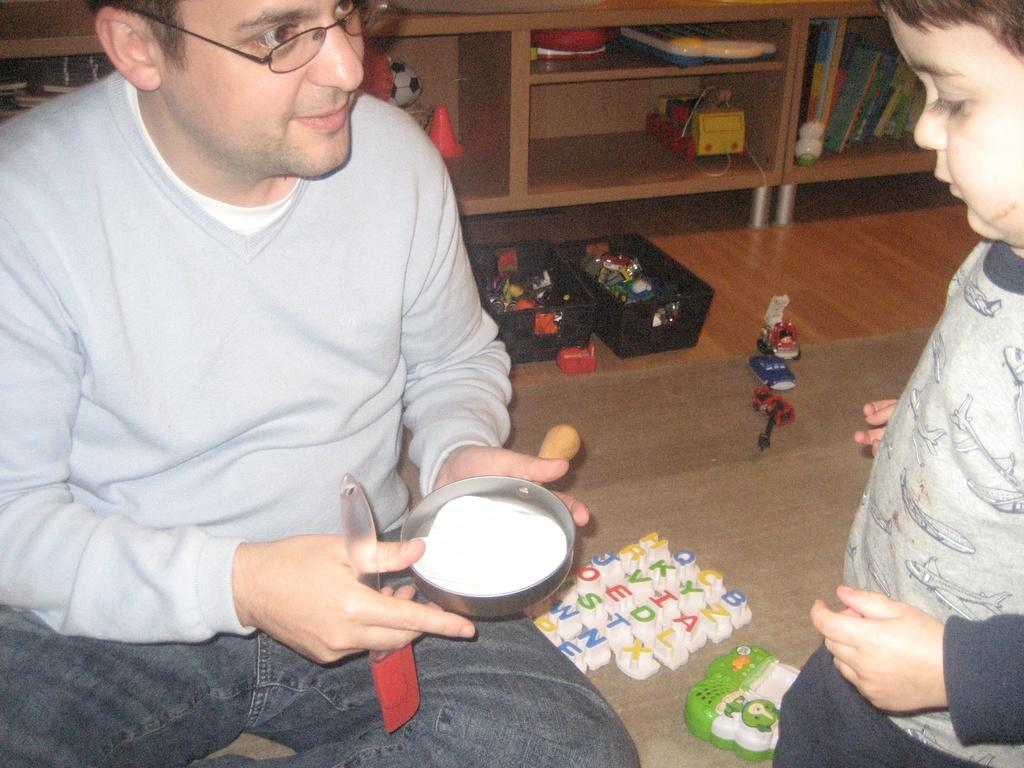What is the main subject of the image? There is a kid standing in the image. What is the man in the image doing? The man is sitting and holding a pastry brush and an object. What can be seen in the image besides the people? There are toys, baskets, books, and other objects in the image. Can you see any airports in the image? No, there are no airports present in the image. What type of net is being used to catch the bursting objects in the image? There are no bursting objects or nets present in the image. 